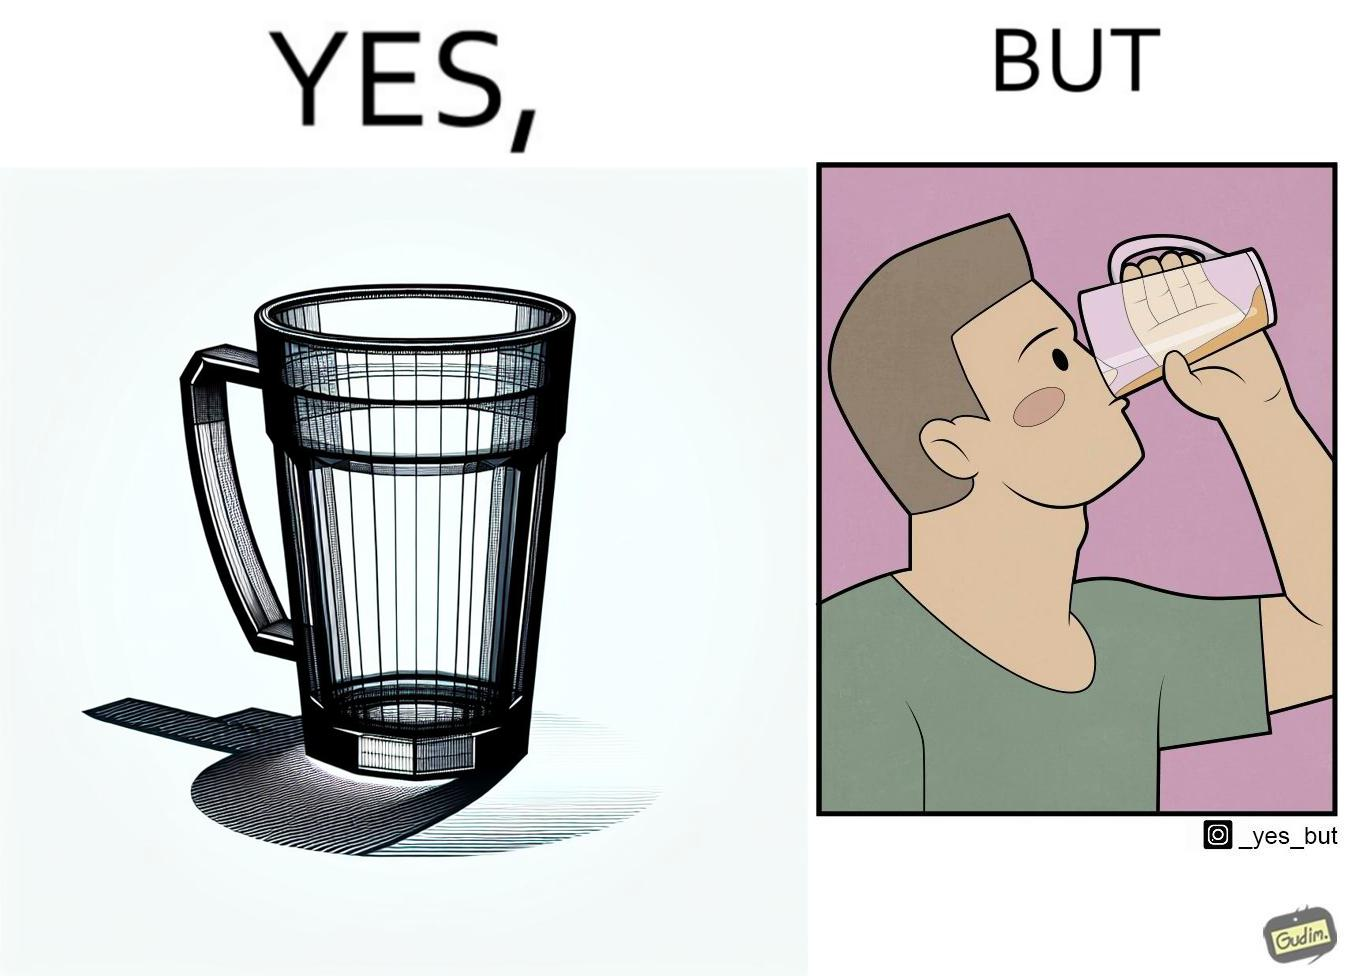What is the satirical meaning behind this image? This image is funny because even though the tumbler has a glass handle on it to facilitate holding, the person drinking from it doesn't use the handle making it redundant. 